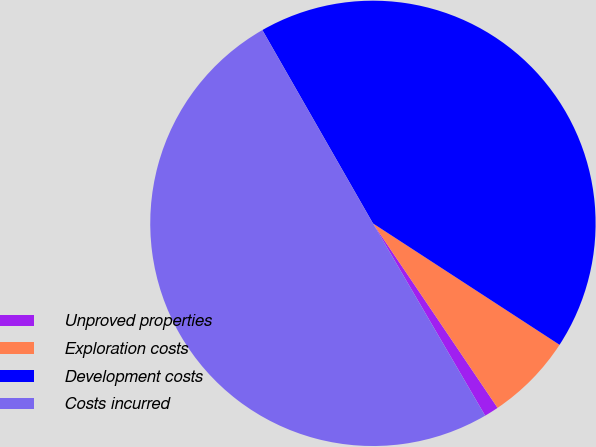Convert chart to OTSL. <chart><loc_0><loc_0><loc_500><loc_500><pie_chart><fcel>Unproved properties<fcel>Exploration costs<fcel>Development costs<fcel>Costs incurred<nl><fcel>1.05%<fcel>6.36%<fcel>42.45%<fcel>50.14%<nl></chart> 